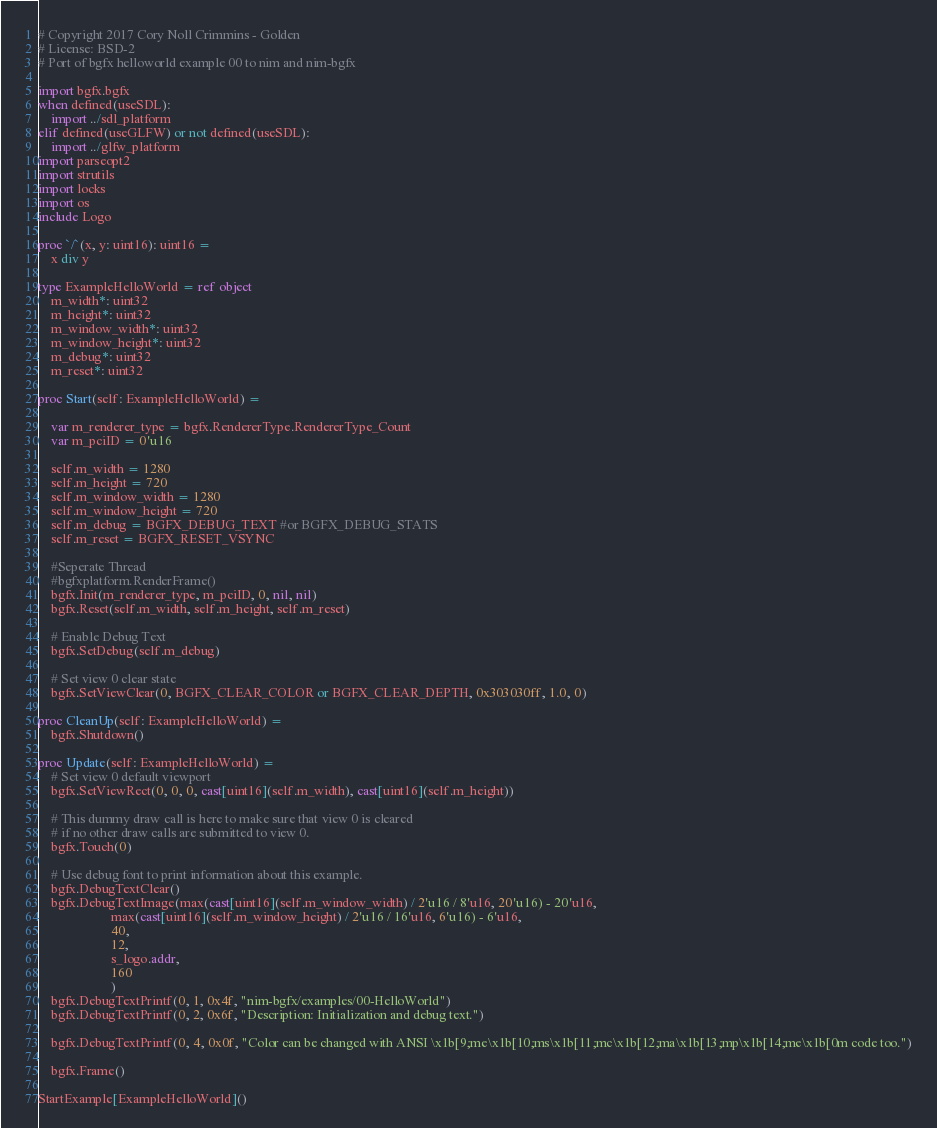<code> <loc_0><loc_0><loc_500><loc_500><_Nim_># Copyright 2017 Cory Noll Crimmins - Golden
# License: BSD-2
# Port of bgfx helloworld example 00 to nim and nim-bgfx

import bgfx.bgfx
when defined(useSDL):
    import ../sdl_platform
elif defined(useGLFW) or not defined(useSDL):
    import ../glfw_platform
import parseopt2
import strutils
import locks
import os
include Logo

proc `/`(x, y: uint16): uint16 =
    x div y

type ExampleHelloWorld = ref object
    m_width*: uint32
    m_height*: uint32
    m_window_width*: uint32
    m_window_height*: uint32
    m_debug*: uint32
    m_reset*: uint32

proc Start(self: ExampleHelloWorld) =

    var m_renderer_type = bgfx.RendererType.RendererType_Count
    var m_pciID = 0'u16

    self.m_width = 1280
    self.m_height = 720
    self.m_window_width = 1280
    self.m_window_height = 720
    self.m_debug = BGFX_DEBUG_TEXT #or BGFX_DEBUG_STATS
    self.m_reset = BGFX_RESET_VSYNC

    #Seperate Thread
    #bgfxplatform.RenderFrame()
    bgfx.Init(m_renderer_type, m_pciID, 0, nil, nil)
    bgfx.Reset(self.m_width, self.m_height, self.m_reset)

    # Enable Debug Text
    bgfx.SetDebug(self.m_debug)

    # Set view 0 clear state
    bgfx.SetViewClear(0, BGFX_CLEAR_COLOR or BGFX_CLEAR_DEPTH, 0x303030ff, 1.0, 0)

proc CleanUp(self: ExampleHelloWorld) =
    bgfx.Shutdown()

proc Update(self: ExampleHelloWorld) =
    # Set view 0 default viewport
    bgfx.SetViewRect(0, 0, 0, cast[uint16](self.m_width), cast[uint16](self.m_height))

    # This dummy draw call is here to make sure that view 0 is cleared
    # if no other draw calls are submitted to view 0.
    bgfx.Touch(0)

    # Use debug font to print information about this example.
    bgfx.DebugTextClear()
    bgfx.DebugTextImage(max(cast[uint16](self.m_window_width) / 2'u16 / 8'u16, 20'u16) - 20'u16,
                      max(cast[uint16](self.m_window_height) / 2'u16 / 16'u16, 6'u16) - 6'u16,
                      40,
                      12,
                      s_logo.addr,
                      160
                      )
    bgfx.DebugTextPrintf(0, 1, 0x4f, "nim-bgfx/examples/00-HelloWorld")
    bgfx.DebugTextPrintf(0, 2, 0x6f, "Description: Initialization and debug text.")

    bgfx.DebugTextPrintf(0, 4, 0x0f, "Color can be changed with ANSI \x1b[9;me\x1b[10;ms\x1b[11;mc\x1b[12;ma\x1b[13;mp\x1b[14;me\x1b[0m code too.")

    bgfx.Frame()

StartExample[ExampleHelloWorld]()
</code> 